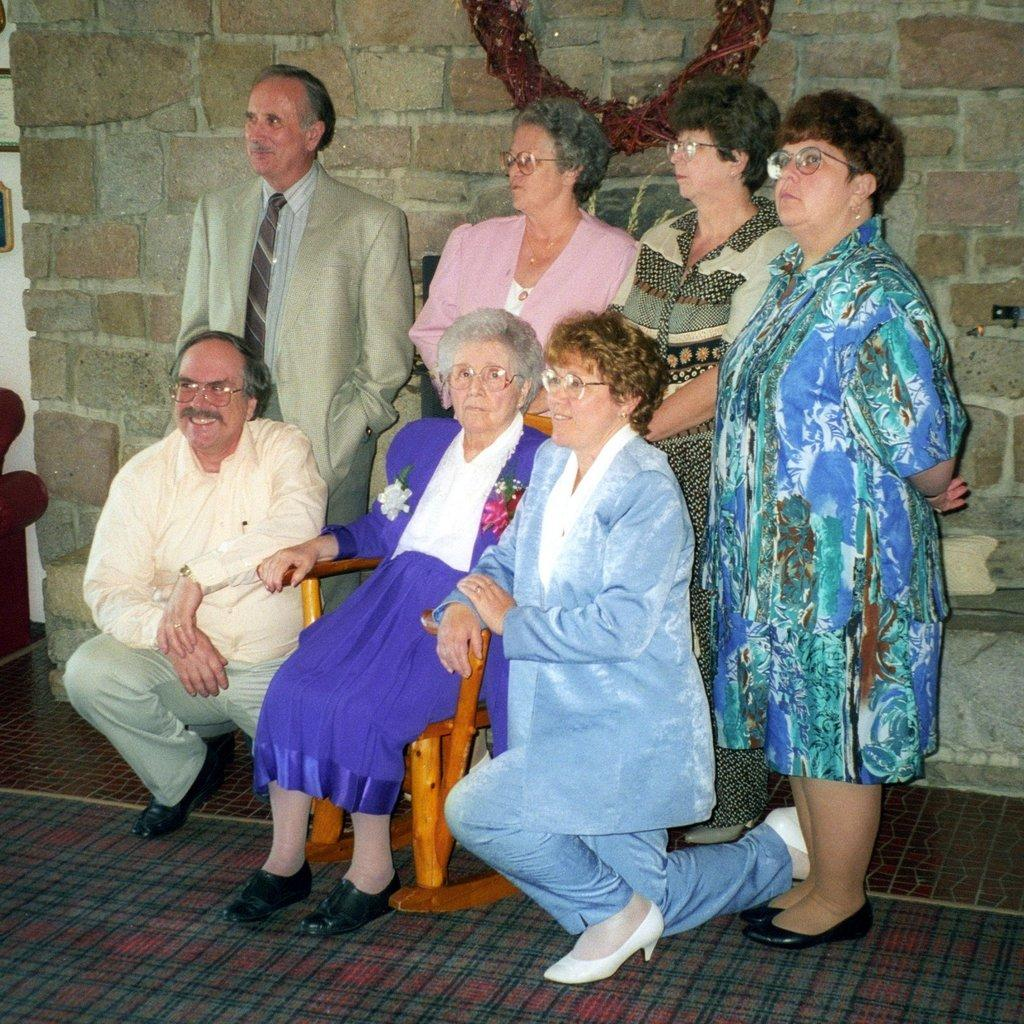What is the woman in the image doing? The woman is sitting on a chair in the image. Are there any other people in the image? Yes, there are people standing around the woman. What can be seen in the background of the image? There appears to be a wall in the background of the image. What type of pipe is the woman holding in the image? There is no pipe present in the image; the woman is sitting on a chair with people standing around her. 